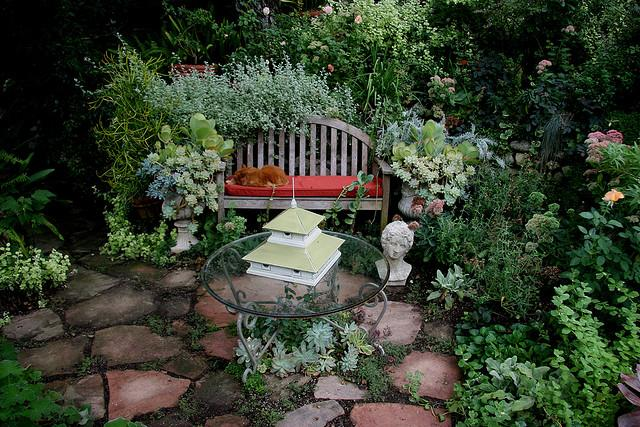What type of statue is to the right front of the bench? Please explain your reasoning. bust. Only the head of the statue is seen. 